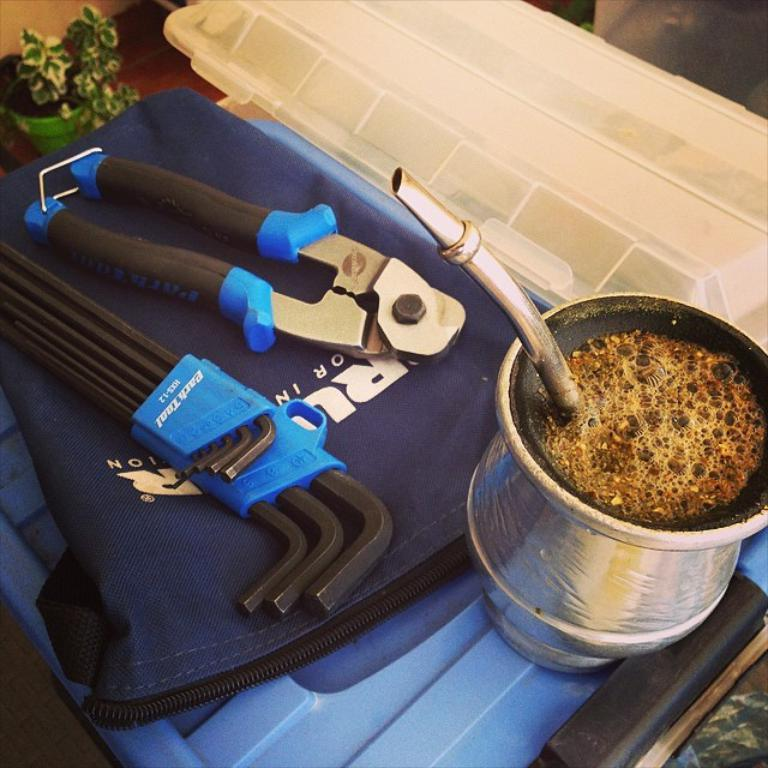What is the main tool visible in the image? There is a wire cutter in the image. What else can be seen in the image besides the wire cutter? There are other tools in the image. Where are the tools located? The tools are on a bag. What is the jug in the image used for? The jug has liquid and an object in it. What type of container is present in the image? There is a box in the image. What type of plant is in the image? There is a houseplant in the image. How many birds are in the flock that is visible in the image? There are no birds or flocks present in the image. 